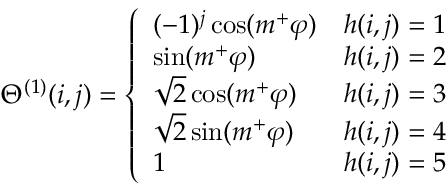Convert formula to latex. <formula><loc_0><loc_0><loc_500><loc_500>\Theta ^ { ( 1 ) } ( i , j ) = \left \{ \begin{array} { l l } { ( - 1 ) ^ { j } \cos ( m ^ { + } \varphi ) } & { h ( i , j ) = 1 } \\ { \sin ( m ^ { + } \varphi ) } & { h ( i , j ) = 2 } \\ { \sqrt { 2 } \cos ( m ^ { + } \varphi ) } & { h ( i , j ) = 3 } \\ { \sqrt { 2 } \sin ( m ^ { + } \varphi ) } & { h ( i , j ) = 4 } \\ { 1 } & { h ( i , j ) = 5 } \end{array}</formula> 